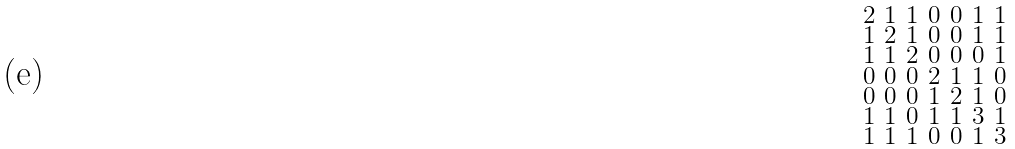<formula> <loc_0><loc_0><loc_500><loc_500>\begin{smallmatrix} 2 & 1 & 1 & 0 & 0 & 1 & 1 \\ 1 & 2 & 1 & 0 & 0 & 1 & 1 \\ 1 & 1 & 2 & 0 & 0 & 0 & 1 \\ 0 & 0 & 0 & 2 & 1 & 1 & 0 \\ 0 & 0 & 0 & 1 & 2 & 1 & 0 \\ 1 & 1 & 0 & 1 & 1 & 3 & 1 \\ 1 & 1 & 1 & 0 & 0 & 1 & 3 \end{smallmatrix}</formula> 